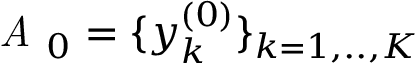Convert formula to latex. <formula><loc_0><loc_0><loc_500><loc_500>A _ { 0 } = \{ y _ { k } ^ { ( 0 ) } \} _ { k = 1 , . . , K }</formula> 